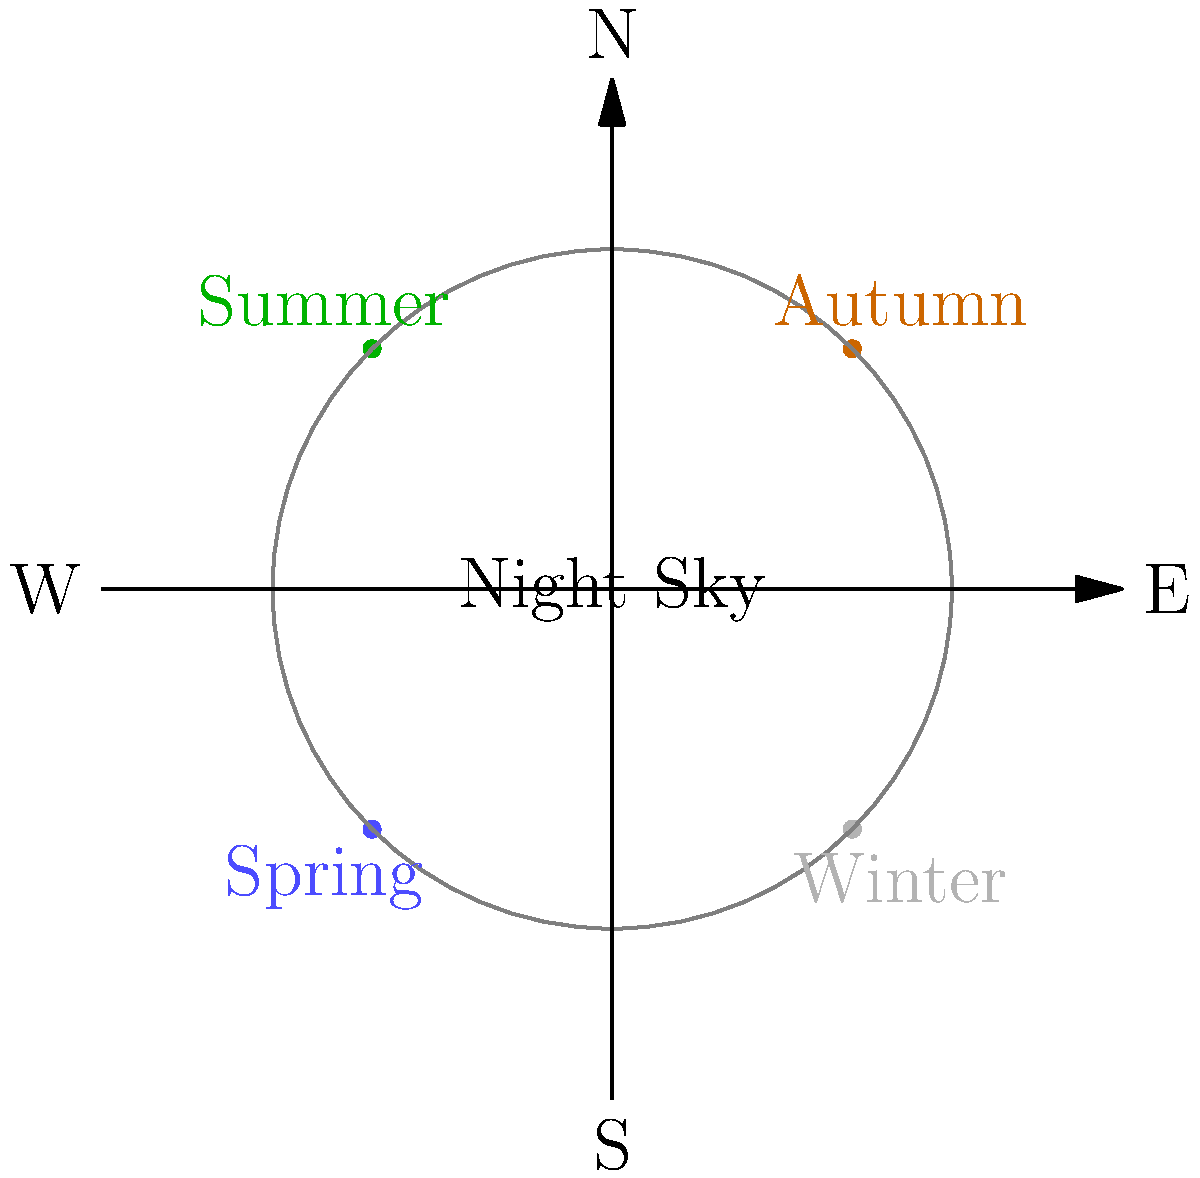As a single mother dealing with home renovation issues, you find solace in stargazing. Which constellation, often associated with strength and perseverance, is prominently visible in the northern sky during autumn evenings? To answer this question, let's follow these steps:

1. Understand the seasonal context: The question specifies autumn evenings.

2. Consider the northern sky: We're looking for a constellation visible in the northern part of the sky.

3. Think about constellations associated with strength and perseverance: This hint narrows down our options.

4. Recall autumn constellations: Some prominent autumn constellations include Cassiopeia, Pegasus, and Andromeda. However, these are not typically associated with strength and perseverance.

5. Consider circumpolar constellations: These are visible year-round in the northern sky, including Ursa Major and Ursa Minor.

6. Identify the correct constellation: Ursa Major, also known as the Great Bear, is often associated with strength and endurance. It's a circumpolar constellation, meaning it's visible year-round in the northern sky, including during autumn evenings.

7. Verify the symbolism: In many cultures, bears are symbols of strength, courage, and perseverance – qualities that resonate with the challenges faced by a single mother dealing with home renovation issues.
Answer: Ursa Major 